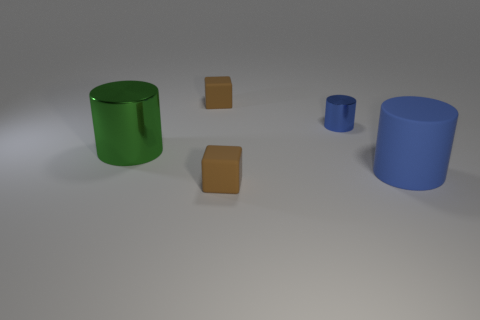There is a rubber object that is the same color as the small metal cylinder; what size is it?
Your response must be concise. Large. Do the small shiny cylinder and the big rubber cylinder have the same color?
Provide a succinct answer. Yes. What number of objects are either matte objects or big brown matte blocks?
Offer a very short reply. 3. Does the tiny brown cube that is behind the blue metallic cylinder have the same material as the big blue cylinder?
Provide a succinct answer. Yes. How big is the green thing?
Give a very brief answer. Large. How many cylinders are either tiny brown objects or blue things?
Make the answer very short. 2. Are there an equal number of tiny metallic cylinders in front of the blue matte thing and blue metallic objects that are in front of the big shiny cylinder?
Your response must be concise. Yes. The blue shiny thing that is the same shape as the large green shiny thing is what size?
Provide a short and direct response. Small. There is a cylinder that is in front of the blue metal cylinder and behind the big rubber cylinder; what size is it?
Provide a short and direct response. Large. There is a large matte cylinder; are there any big cylinders on the left side of it?
Give a very brief answer. Yes. 